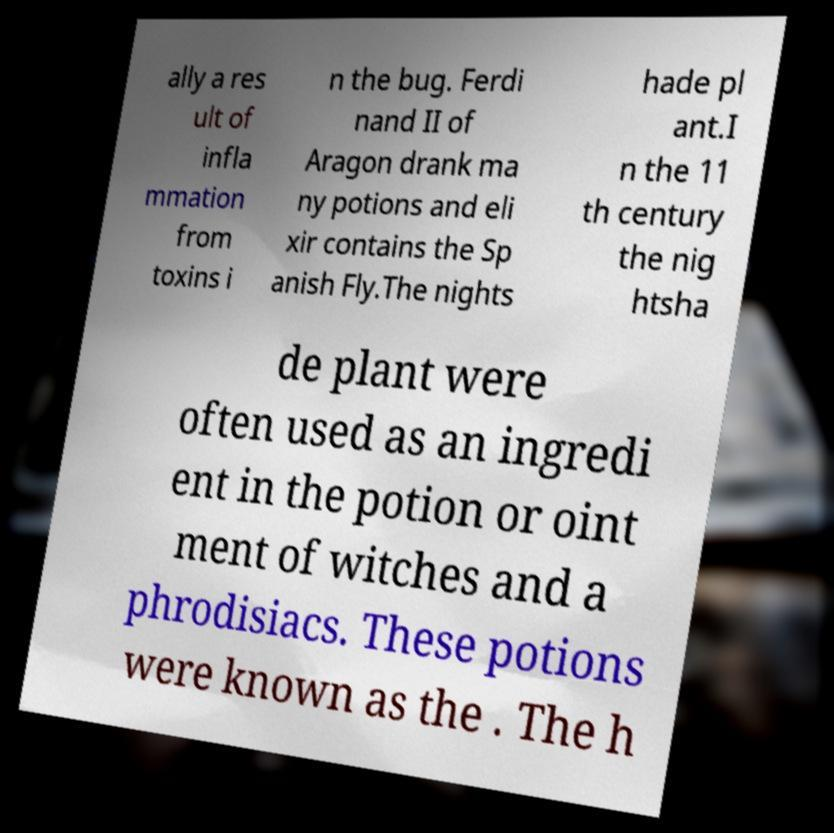Could you assist in decoding the text presented in this image and type it out clearly? ally a res ult of infla mmation from toxins i n the bug. Ferdi nand II of Aragon drank ma ny potions and eli xir contains the Sp anish Fly.The nights hade pl ant.I n the 11 th century the nig htsha de plant were often used as an ingredi ent in the potion or oint ment of witches and a phrodisiacs. These potions were known as the . The h 